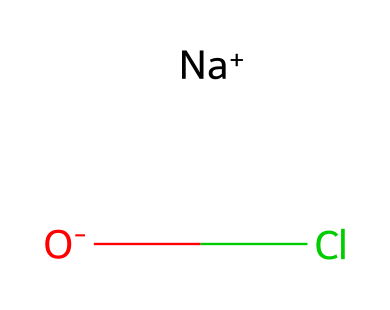What is the name of the compound represented by this structure? The structure provided is sodium hypochlorite, which is identified by the sodium ion, hypochlorite ion, and chlorine atom present in its composition.
Answer: sodium hypochlorite How many atoms are present in sodium hypochlorite? The molecule contains four atoms: one sodium atom, one oxygen atom, one chlorine atom, and one additional oxygen from the hypochlorite ion.
Answer: four What is the oxidation state of chlorine in sodium hypochlorite? The oxidation state of chlorine in sodium hypochlorite is +1, as it bonds with the oxygen in the hypochlorite ion with a lower oxidation state compared to its elemental form.
Answer: +1 Which atom is responsible for the oxidizing properties of sodium hypochlorite? The oxygen atom in the hypochlorite ion, which is characteristic of oxidizing agents, is responsible for these properties, allowing reactions that involve the transfer of electrons.
Answer: oxygen What type of chemical bond exists between the sodium and the hypochlorite ion? The bond between the sodium ion and the hypochlorite ion is an ionic bond, as sodium donates an electron to stabilize the hypochlorite, creating charged ions that attract each other.
Answer: ionic bond What role does sodium hypochlorite play in disinfection? Sodium hypochlorite serves as a strong oxidizer, effectively disrupting cellular structures and killing pathogens through its oxidation reactions.
Answer: disinfectant 